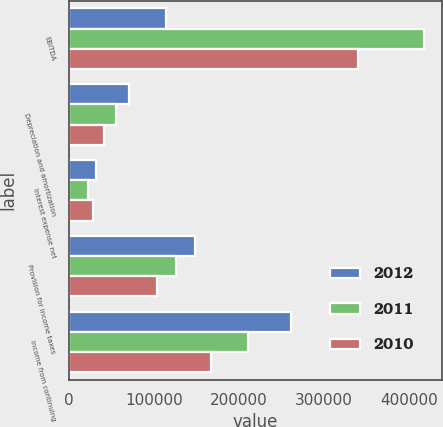Convert chart. <chart><loc_0><loc_0><loc_500><loc_500><stacked_bar_chart><ecel><fcel>EBITDA<fcel>Depreciation and amortization<fcel>Interest expense net<fcel>Provision for income taxes<fcel>Income from continuing<nl><fcel>2012<fcel>114257<fcel>70165<fcel>31215<fcel>147942<fcel>261225<nl><fcel>2011<fcel>418068<fcel>54505<fcel>22447<fcel>125507<fcel>210264<nl><fcel>2010<fcel>339869<fcel>41428<fcel>28316<fcel>103007<fcel>167118<nl></chart> 